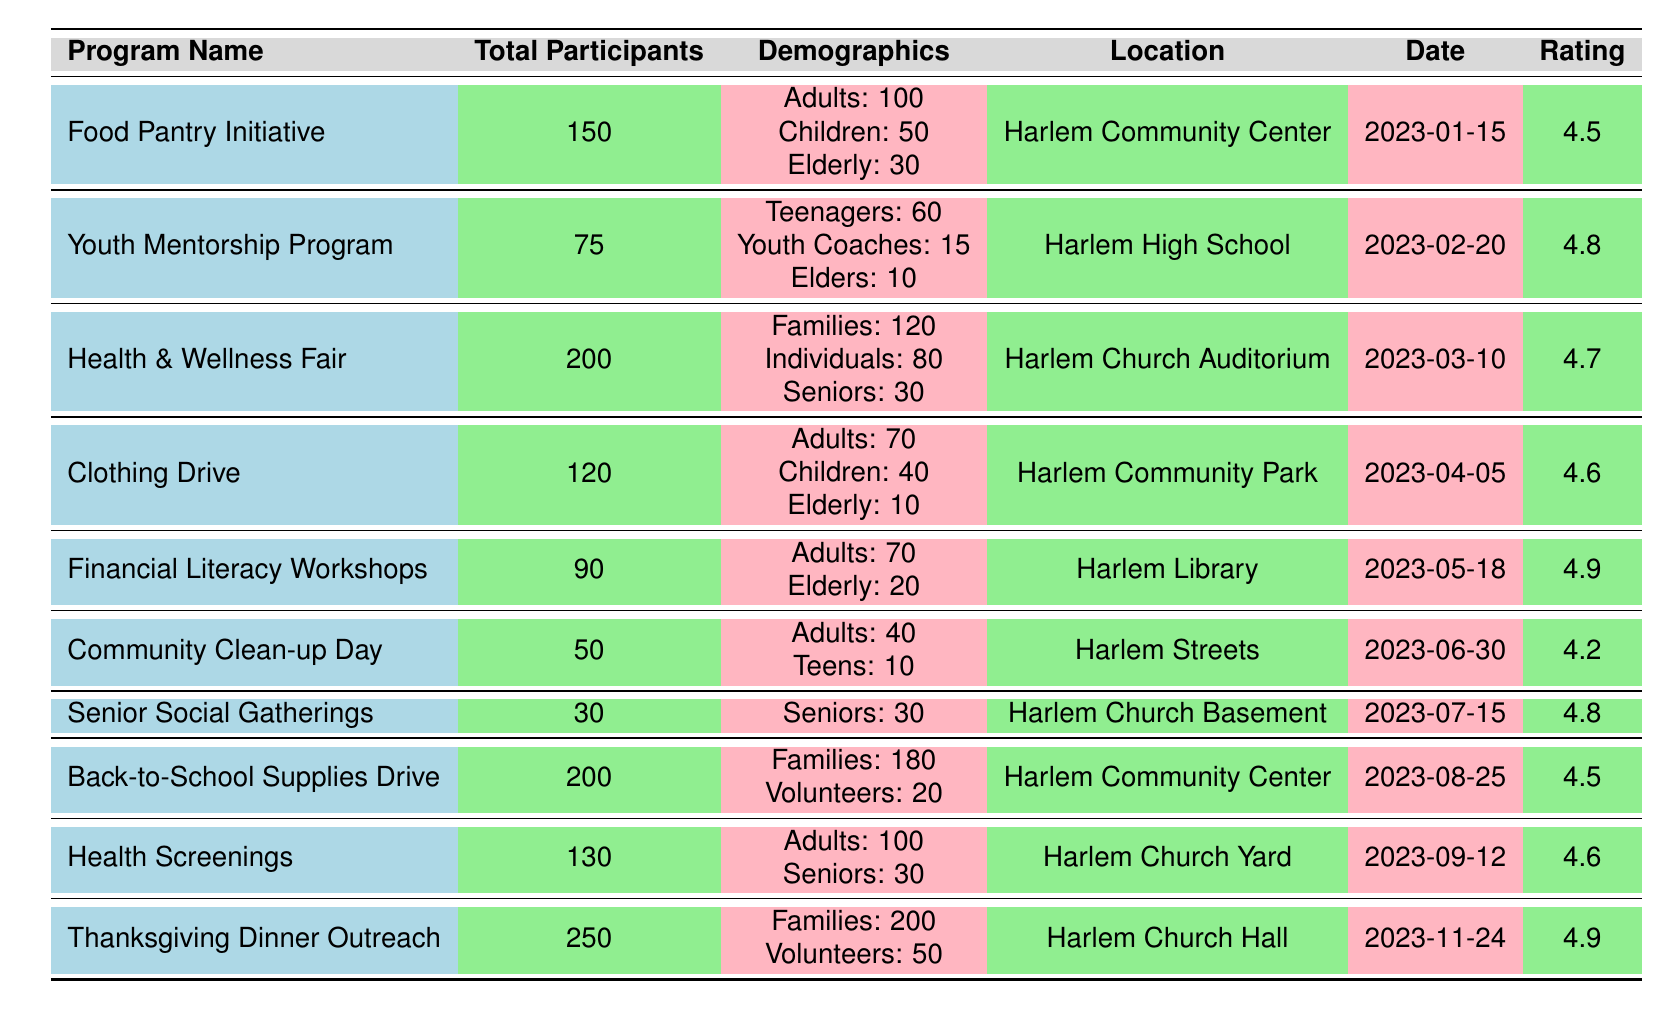What is the total number of participants in the Food Pantry Initiative? The table lists "Total Participants" for the Food Pantry Initiative as 150.
Answer: 150 How many elderly people participated in the Clothing Drive? The demographics section for the Clothing Drive shows "Elderly: 10".
Answer: 10 Which program received the highest feedback rating? By comparing the ratings in the table, "Thanksgiving Dinner Outreach" and "Financial Literacy Workshops" both have the highest rating of 4.9.
Answer: Thanksgiving Dinner Outreach and Financial Literacy Workshops What is the average feedback rating across all programs? The ratings are 4.5, 4.8, 4.7, 4.6, 4.9, 4.2, 4.8, 4.5, 4.6, 4.9. Summing them gives 47.5, and dividing by 10 (the number of programs) results in 4.75.
Answer: 4.75 How many programs have more than 100 total participants? By examining the "Total Participants" column, the programs are: Health & Wellness Fair (200), Back-to-School Supplies Drive (200), and Thanksgiving Dinner Outreach (250). That's 3 programs.
Answer: 3 Did the Youth Mentorship Program receive a rating higher than 4.5? The Youth Mentorship Program has a feedback rating of 4.8, which is higher than 4.5.
Answer: Yes What is the total number of participants across all Outreach Programs? The total participants for each program are 150 + 75 + 200 + 120 + 90 + 50 + 30 + 200 + 130 + 250 = 1,395.
Answer: 1,395 Which program had the lowest participation numbers? "Senior Social Gatherings" had the lowest with 30 participants.
Answer: Senior Social Gatherings Calculate the difference in total participants between the Thanksgiving Dinner Outreach and the Community Clean-up Day. Thanksgiving Dinner Outreach had 250 participants and Community Clean-up Day had 50, so the difference is 250 - 50 = 200.
Answer: 200 How many participants were children in total for all the programs listed? The programs with children's participation are Food Pantry Initiative (50), Clothing Drive (40), and Back-to-School Supplies Drive (180), totaling 50 + 40 + 180 = 270 children.
Answer: 270 